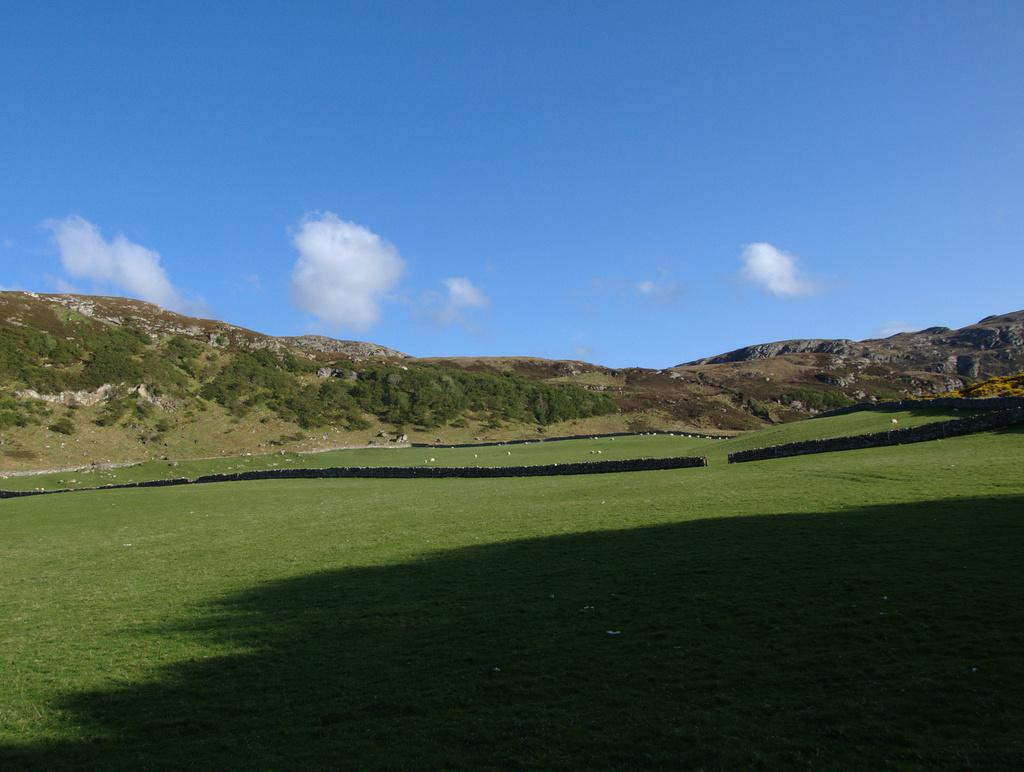What is located in the center of the image? There are hills and trees in the center of the image. What is visible at the bottom of the image? There is ground visible at the bottom of the image, and grass is present there. What can be seen in the sky at the top of the image? Clouds are present in the sky at the top of the image. Can you tell me how many feathers are on the side of the hills in the image? There are no feathers present in the image; it features hills, trees, ground, grass, and clouds. What type of milk can be seen flowing down the side of the hills in the image? There is no milk present in the image; it features hills, trees, ground, grass, and clouds. 